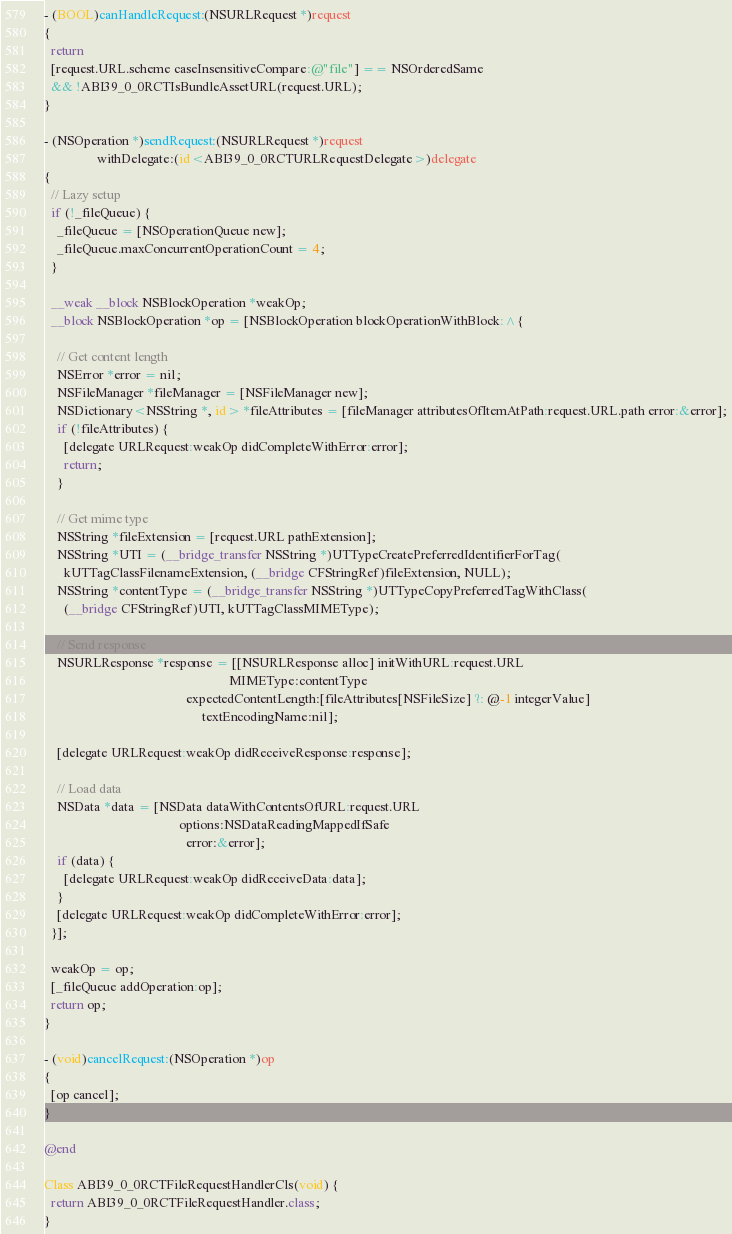<code> <loc_0><loc_0><loc_500><loc_500><_ObjectiveC_>
- (BOOL)canHandleRequest:(NSURLRequest *)request
{
  return
  [request.URL.scheme caseInsensitiveCompare:@"file"] == NSOrderedSame
  && !ABI39_0_0RCTIsBundleAssetURL(request.URL);
}

- (NSOperation *)sendRequest:(NSURLRequest *)request
                withDelegate:(id<ABI39_0_0RCTURLRequestDelegate>)delegate
{
  // Lazy setup
  if (!_fileQueue) {
    _fileQueue = [NSOperationQueue new];
    _fileQueue.maxConcurrentOperationCount = 4;
  }

  __weak __block NSBlockOperation *weakOp;
  __block NSBlockOperation *op = [NSBlockOperation blockOperationWithBlock:^{

    // Get content length
    NSError *error = nil;
    NSFileManager *fileManager = [NSFileManager new];
    NSDictionary<NSString *, id> *fileAttributes = [fileManager attributesOfItemAtPath:request.URL.path error:&error];
    if (!fileAttributes) {
      [delegate URLRequest:weakOp didCompleteWithError:error];
      return;
    }

    // Get mime type
    NSString *fileExtension = [request.URL pathExtension];
    NSString *UTI = (__bridge_transfer NSString *)UTTypeCreatePreferredIdentifierForTag(
      kUTTagClassFilenameExtension, (__bridge CFStringRef)fileExtension, NULL);
    NSString *contentType = (__bridge_transfer NSString *)UTTypeCopyPreferredTagWithClass(
      (__bridge CFStringRef)UTI, kUTTagClassMIMEType);

    // Send response
    NSURLResponse *response = [[NSURLResponse alloc] initWithURL:request.URL
                                                        MIMEType:contentType
                                           expectedContentLength:[fileAttributes[NSFileSize] ?: @-1 integerValue]
                                                textEncodingName:nil];

    [delegate URLRequest:weakOp didReceiveResponse:response];

    // Load data
    NSData *data = [NSData dataWithContentsOfURL:request.URL
                                         options:NSDataReadingMappedIfSafe
                                           error:&error];
    if (data) {
      [delegate URLRequest:weakOp didReceiveData:data];
    }
    [delegate URLRequest:weakOp didCompleteWithError:error];
  }];

  weakOp = op;
  [_fileQueue addOperation:op];
  return op;
}

- (void)cancelRequest:(NSOperation *)op
{
  [op cancel];
}

@end

Class ABI39_0_0RCTFileRequestHandlerCls(void) {
  return ABI39_0_0RCTFileRequestHandler.class;
}
</code> 